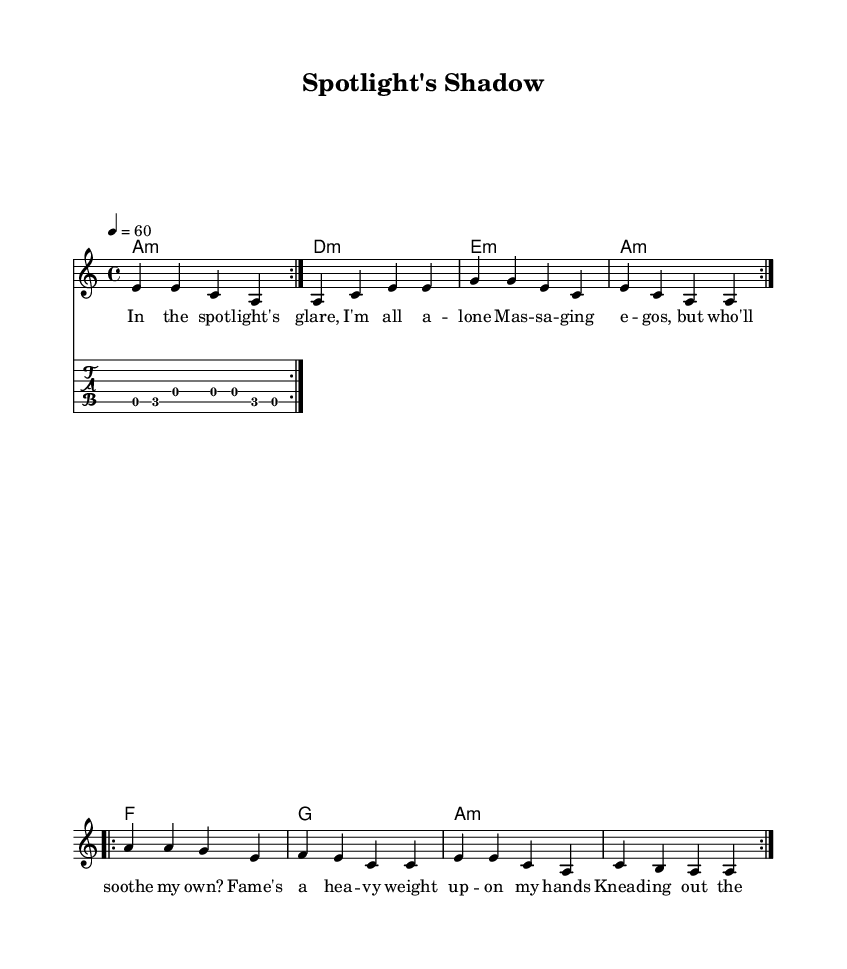What is the key signature of this music? The key signature is indicated by the "key" command at the beginning of the global settings. It shows "a minor", which means the music is in the key of A minor.
Answer: A minor What is the time signature of this piece? The time signature is also set in the global context with the notation "4/4". This means there are four beats in each measure and the quarter note receives one beat.
Answer: 4/4 What is the tempo marking indicated in the score? The tempo is marked with "4 = 60" in the global settings, indicating that a quarter note gets sixty beats per minute.
Answer: 60 How many times does the main melody repeat? The main melody section has a "repeat volta 2" marking, which indicates that the melody is repeated twice.
Answer: 2 What is the first chord in the harmony section? The first chord is represented in the harmony section with "a1:m", which indicates that the first chord is an A minor chord played for a whole note.
Answer: A minor What lyric corresponds to the first measure of the melody? The lyrics provided in the verseWords section start with "In the spot -- light's glare, I'm all a -- lone", which corresponds to the first measure of the melody in the score.
Answer: In the spotlight's glare, I'm all alone What type of riff is indicated in the score? The riff is specified as a "Guitar Riff" with a note in the score using the "override TextSpanner" command to indicate that it is a guitar section.
Answer: Guitar Riff 